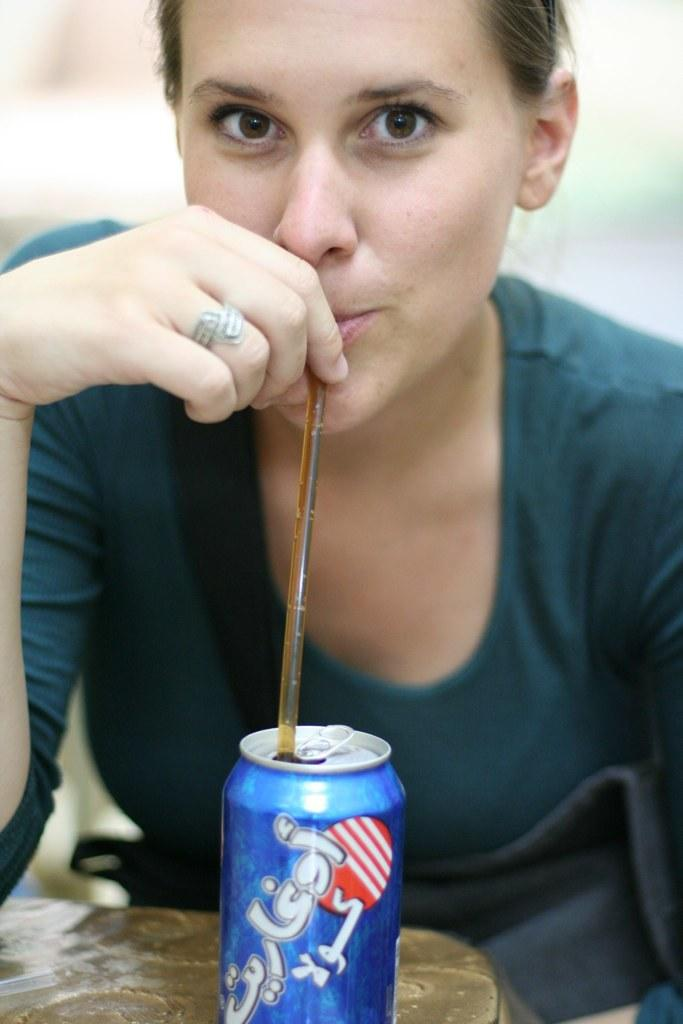Who is present in the image? There is a woman in the image. What is the woman wearing? The woman is wearing a green t-shirt. What is the woman doing in the image? The woman is drinking a drink through a straw. What can be seen in front of the woman? There is a blue can in front of the woman. What type of education does the man in the image have? There is no man present in the image; it features a woman. How does the woman show respect to others in the image? The image does not provide information about the woman showing respect to others. 